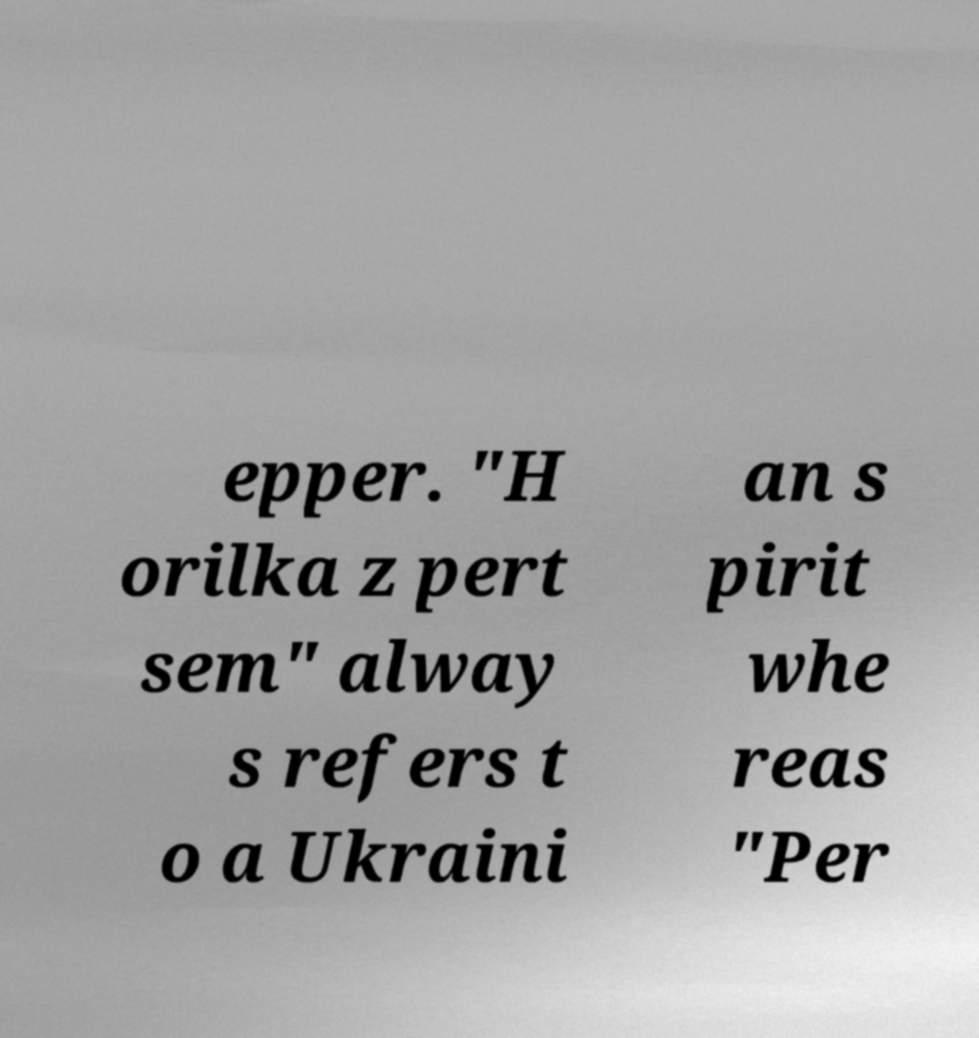There's text embedded in this image that I need extracted. Can you transcribe it verbatim? epper. "H orilka z pert sem" alway s refers t o a Ukraini an s pirit whe reas "Per 